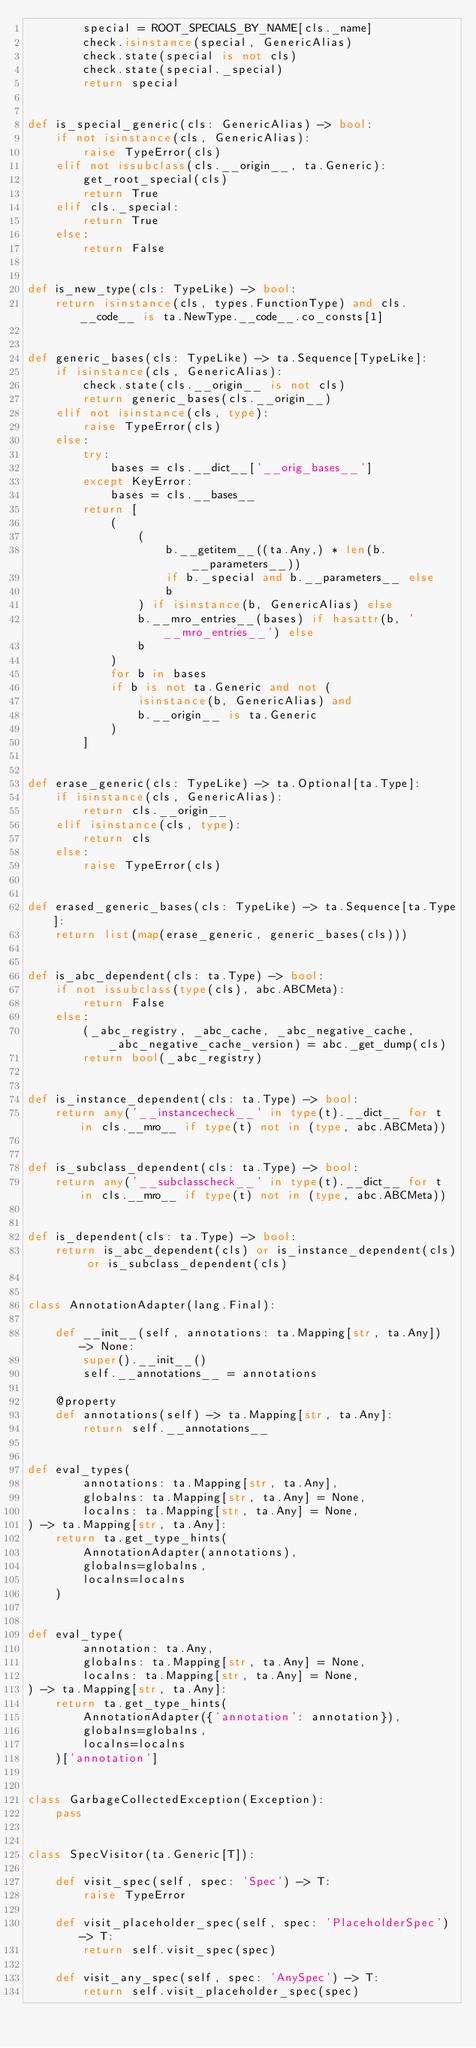Convert code to text. <code><loc_0><loc_0><loc_500><loc_500><_Python_>        special = ROOT_SPECIALS_BY_NAME[cls._name]
        check.isinstance(special, GenericAlias)
        check.state(special is not cls)
        check.state(special._special)
        return special


def is_special_generic(cls: GenericAlias) -> bool:
    if not isinstance(cls, GenericAlias):
        raise TypeError(cls)
    elif not issubclass(cls.__origin__, ta.Generic):
        get_root_special(cls)
        return True
    elif cls._special:
        return True
    else:
        return False


def is_new_type(cls: TypeLike) -> bool:
    return isinstance(cls, types.FunctionType) and cls.__code__ is ta.NewType.__code__.co_consts[1]


def generic_bases(cls: TypeLike) -> ta.Sequence[TypeLike]:
    if isinstance(cls, GenericAlias):
        check.state(cls.__origin__ is not cls)
        return generic_bases(cls.__origin__)
    elif not isinstance(cls, type):
        raise TypeError(cls)
    else:
        try:
            bases = cls.__dict__['__orig_bases__']
        except KeyError:
            bases = cls.__bases__
        return [
            (
                (
                    b.__getitem__((ta.Any,) * len(b.__parameters__))
                    if b._special and b.__parameters__ else
                    b
                ) if isinstance(b, GenericAlias) else
                b.__mro_entries__(bases) if hasattr(b, '__mro_entries__') else
                b
            )
            for b in bases
            if b is not ta.Generic and not (
                isinstance(b, GenericAlias) and
                b.__origin__ is ta.Generic
            )
        ]


def erase_generic(cls: TypeLike) -> ta.Optional[ta.Type]:
    if isinstance(cls, GenericAlias):
        return cls.__origin__
    elif isinstance(cls, type):
        return cls
    else:
        raise TypeError(cls)


def erased_generic_bases(cls: TypeLike) -> ta.Sequence[ta.Type]:
    return list(map(erase_generic, generic_bases(cls)))


def is_abc_dependent(cls: ta.Type) -> bool:
    if not issubclass(type(cls), abc.ABCMeta):
        return False
    else:
        (_abc_registry, _abc_cache, _abc_negative_cache, _abc_negative_cache_version) = abc._get_dump(cls)
        return bool(_abc_registry)


def is_instance_dependent(cls: ta.Type) -> bool:
    return any('__instancecheck__' in type(t).__dict__ for t in cls.__mro__ if type(t) not in (type, abc.ABCMeta))


def is_subclass_dependent(cls: ta.Type) -> bool:
    return any('__subclasscheck__' in type(t).__dict__ for t in cls.__mro__ if type(t) not in (type, abc.ABCMeta))


def is_dependent(cls: ta.Type) -> bool:
    return is_abc_dependent(cls) or is_instance_dependent(cls) or is_subclass_dependent(cls)


class AnnotationAdapter(lang.Final):

    def __init__(self, annotations: ta.Mapping[str, ta.Any]) -> None:
        super().__init__()
        self.__annotations__ = annotations

    @property
    def annotations(self) -> ta.Mapping[str, ta.Any]:
        return self.__annotations__


def eval_types(
        annotations: ta.Mapping[str, ta.Any],
        globalns: ta.Mapping[str, ta.Any] = None,
        localns: ta.Mapping[str, ta.Any] = None,
) -> ta.Mapping[str, ta.Any]:
    return ta.get_type_hints(
        AnnotationAdapter(annotations),
        globalns=globalns,
        localns=localns
    )


def eval_type(
        annotation: ta.Any,
        globalns: ta.Mapping[str, ta.Any] = None,
        localns: ta.Mapping[str, ta.Any] = None,
) -> ta.Mapping[str, ta.Any]:
    return ta.get_type_hints(
        AnnotationAdapter({'annotation': annotation}),
        globalns=globalns,
        localns=localns
    )['annotation']


class GarbageCollectedException(Exception):
    pass


class SpecVisitor(ta.Generic[T]):

    def visit_spec(self, spec: 'Spec') -> T:
        raise TypeError

    def visit_placeholder_spec(self, spec: 'PlaceholderSpec') -> T:
        return self.visit_spec(spec)

    def visit_any_spec(self, spec: 'AnySpec') -> T:
        return self.visit_placeholder_spec(spec)
</code> 